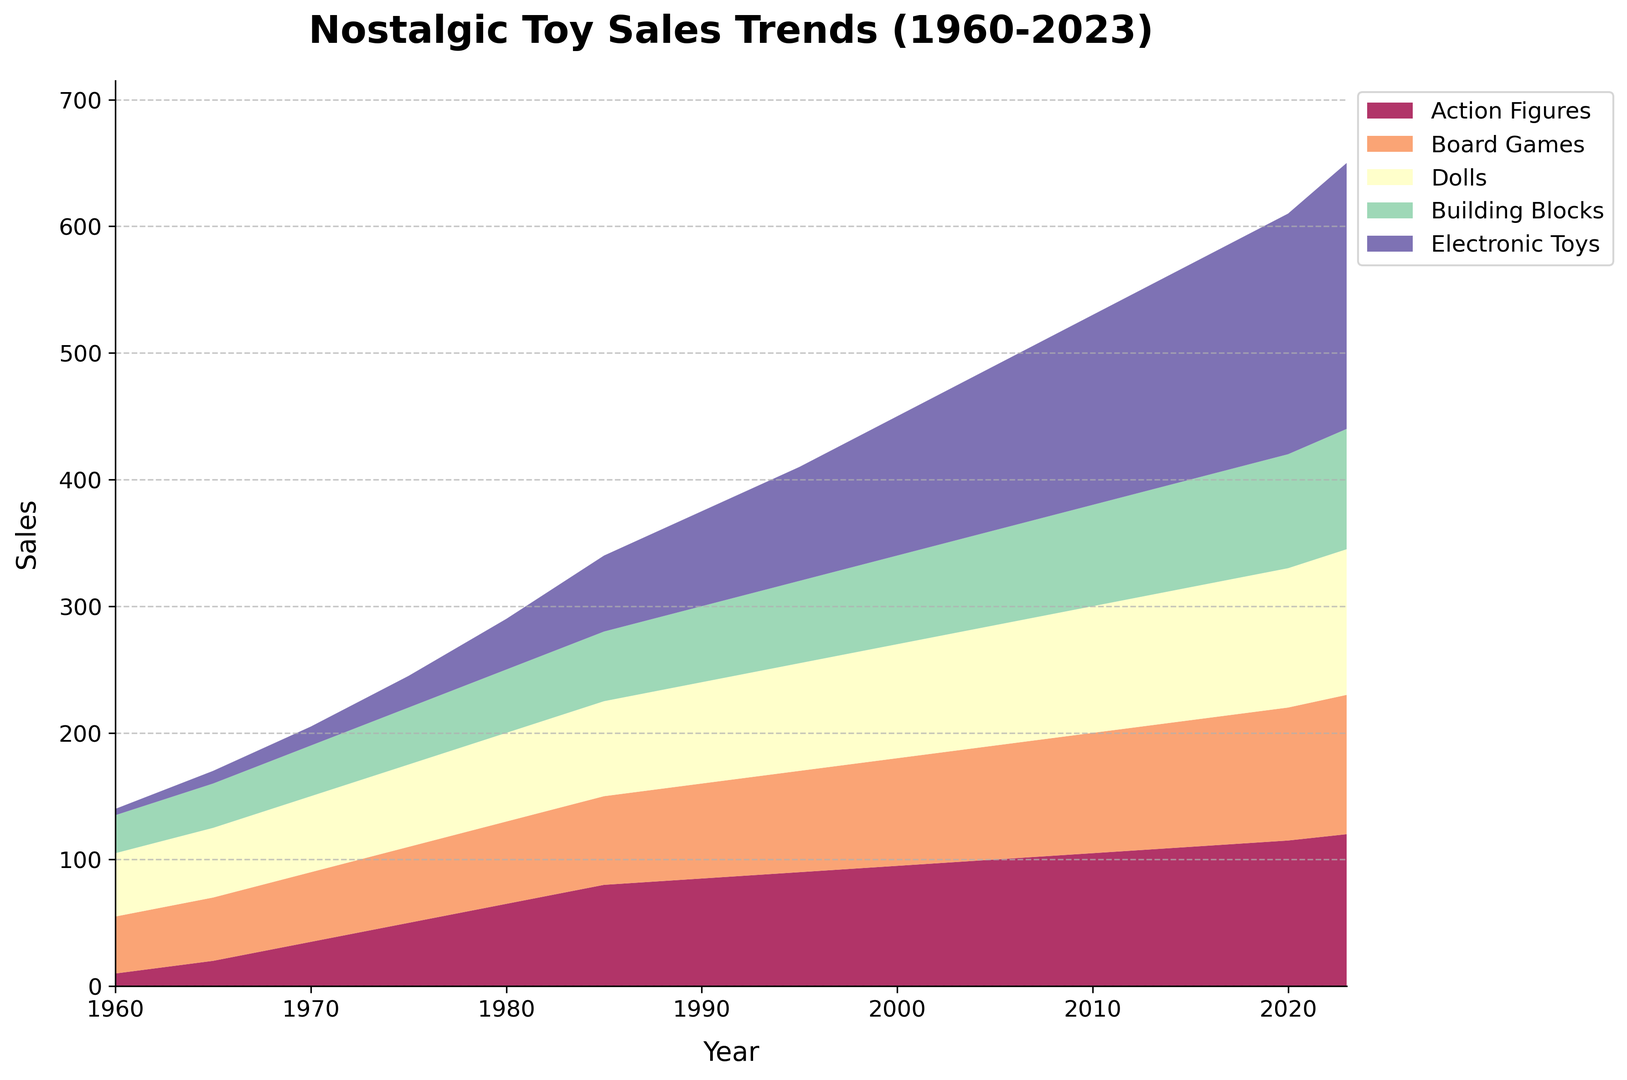What year does the figure start tracking toy sales? Look at the leftmost point on the x-axis to find the starting year.
Answer: 1960 Which toy category had the highest sales in 1980? Check the y-values for each toy category at the 1980 mark on the x-axis. The category with the highest y-value will have the highest sales.
Answer: Dolls How do the sales of Action Figures compare between 1965 and 1995? Compare the y-values of Action Figures for the years 1965 and 1995.
Answer: Sales in 1995 are higher than in 1965 Which toy category shows the most significant growth from 1960 to 2023? Identify the difference in the y-values for each toy category between 1960 and 2023. The category with the largest difference shows the most growth.
Answer: Electronic Toys What is the combined sales of Board Games and Dolls in 2010? Locate the y-values for Board Games and Dolls in 2010 and sum them up.
Answer: 195 Between which two years did Electronic Toy sales see the most significant increase? Examine the slope of the area for Electronic Toys between adjacent years. The steepest slope represents the most significant increase.
Answer: 2000 and 2005 What's the average annual sales increase for Building Blocks from 1980 to 2020? Calculate the difference in sales of Building Blocks between 1980 and 2020, then divide by the number of years (40).
Answer: 1 Which toy category had the smallest sales in 1960? Identify the lowest y-value among the toy categories in 1960.
Answer: Electronic Toys In what year did Board Games first surpass 90 in sales? Track the y-values for Board Games and identify the first year they reach or exceed 90.
Answer: 2005 How do the trends of Building Blocks and Dolls from 1960 to 2023 compare? Observe the slope and overall growth over time for both Building Blocks and Dolls. Dolls show more consistent growth while Building Blocks show steadier and slower growth.
Answer: Dolls show more consistent growth 